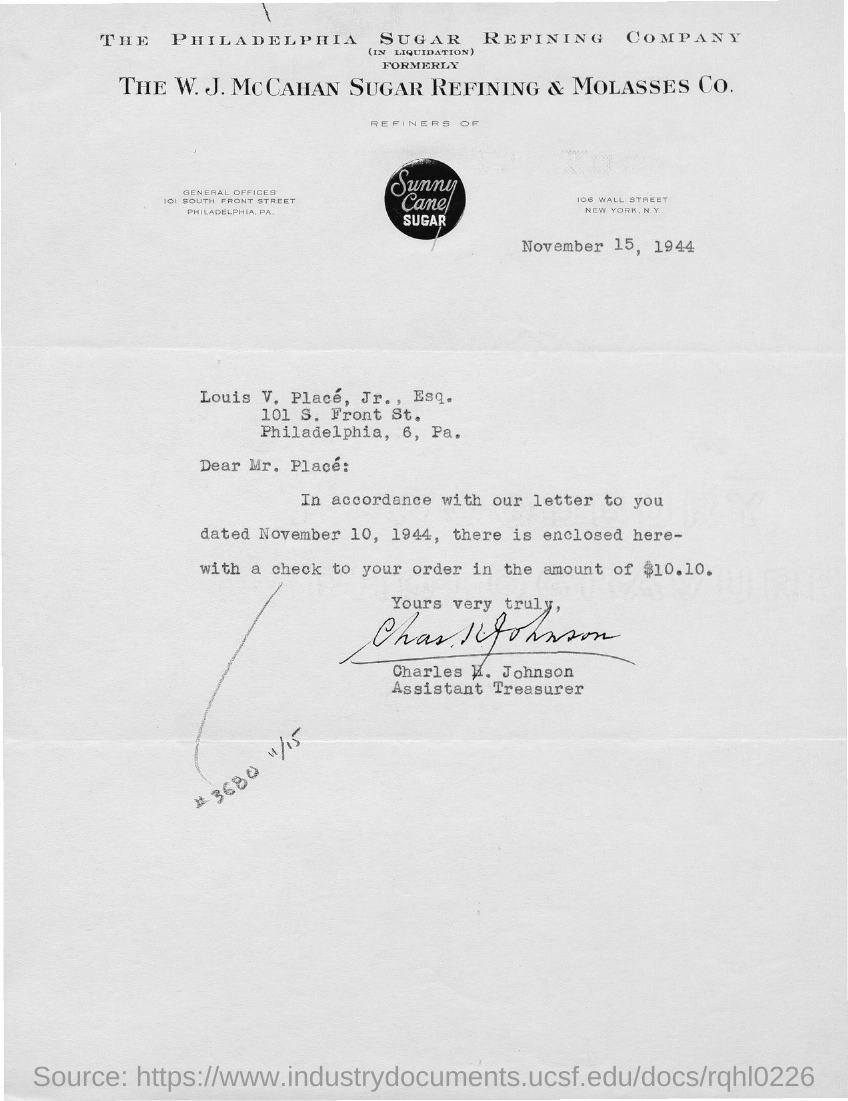Identify some key points in this picture. Charles E. Johnson holds the designation of Assistant Treasurer. The check amount is $10.10. The circular image contains the written phrase "Sunny Cane Sugar. The date of the letter is November 15, 1944. 